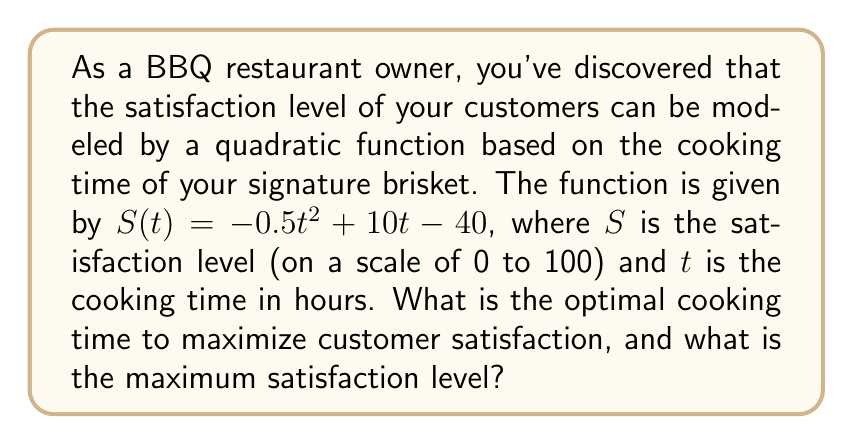Provide a solution to this math problem. 1) The satisfaction function is a quadratic function in the form $S(t) = -0.5t^2 + 10t - 40$.

2) To find the optimal cooking time, we need to find the vertex of this parabola. The vertex represents the maximum point of the function.

3) For a quadratic function in the form $f(x) = ax^2 + bx + c$, the x-coordinate of the vertex is given by $x = -\frac{b}{2a}$.

4) In our case, $a = -0.5$ and $b = 10$. So:

   $t = -\frac{10}{2(-0.5)} = -\frac{10}{-1} = 10$

5) Therefore, the optimal cooking time is 10 hours.

6) To find the maximum satisfaction level, we substitute $t = 10$ into the original function:

   $S(10) = -0.5(10)^2 + 10(10) - 40$
   $= -0.5(100) + 100 - 40$
   $= -50 + 100 - 40$
   $= 10$

7) The maximum satisfaction level is 10.
Answer: Optimal cooking time: 10 hours; Maximum satisfaction level: 10 